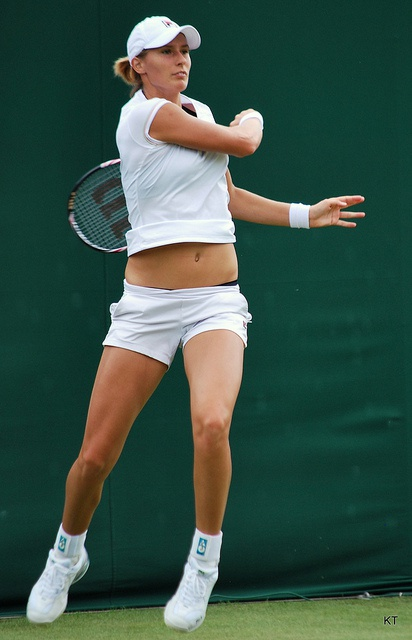Describe the objects in this image and their specific colors. I can see people in black, lightgray, salmon, brown, and tan tones and tennis racket in black and teal tones in this image. 